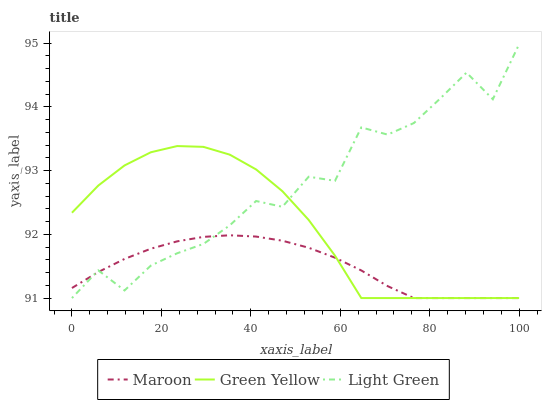Does Maroon have the minimum area under the curve?
Answer yes or no. Yes. Does Light Green have the maximum area under the curve?
Answer yes or no. Yes. Does Light Green have the minimum area under the curve?
Answer yes or no. No. Does Maroon have the maximum area under the curve?
Answer yes or no. No. Is Maroon the smoothest?
Answer yes or no. Yes. Is Light Green the roughest?
Answer yes or no. Yes. Is Light Green the smoothest?
Answer yes or no. No. Is Maroon the roughest?
Answer yes or no. No. Does Green Yellow have the lowest value?
Answer yes or no. Yes. Does Light Green have the highest value?
Answer yes or no. Yes. Does Maroon have the highest value?
Answer yes or no. No. Does Light Green intersect Green Yellow?
Answer yes or no. Yes. Is Light Green less than Green Yellow?
Answer yes or no. No. Is Light Green greater than Green Yellow?
Answer yes or no. No. 